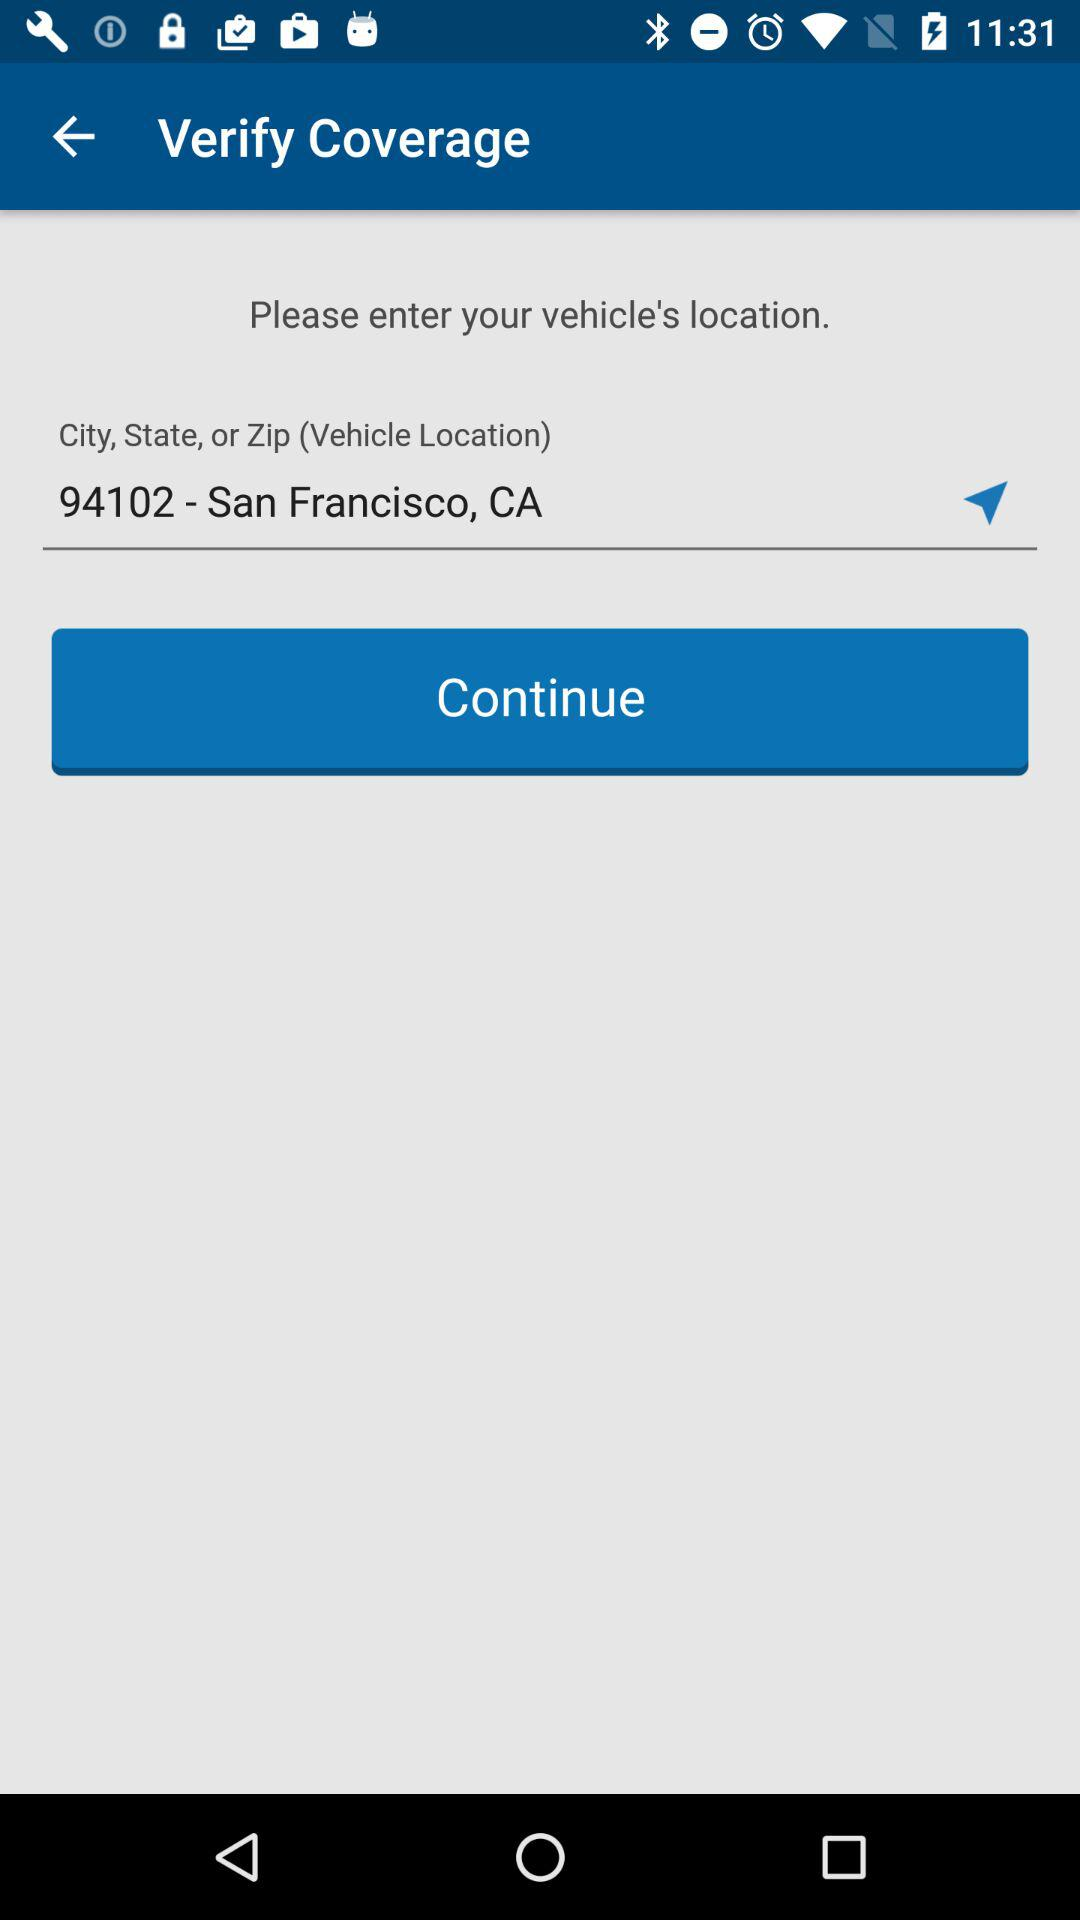What is the Zip code for San Francisco? The Zip code for San Francisco is 94102. 